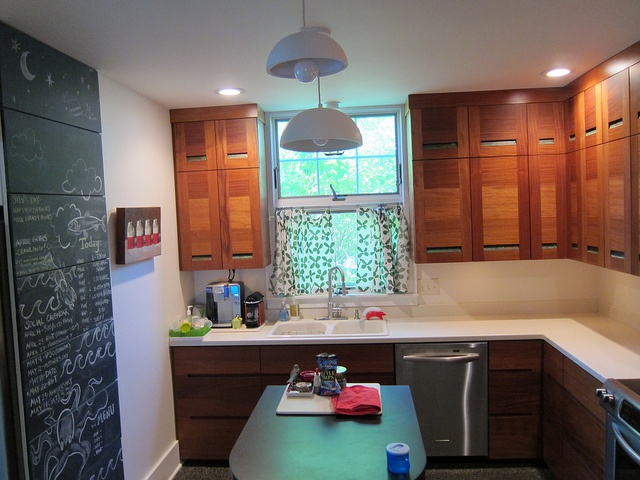Describe the objects in this image and their specific colors. I can see dining table in gray, teal, and black tones, oven in gray, black, and blue tones, sink in gray, darkgray, and lightgray tones, sink in darkgray, tan, lightgray, and gray tones, and bottle in gray, darkgray, and olive tones in this image. 